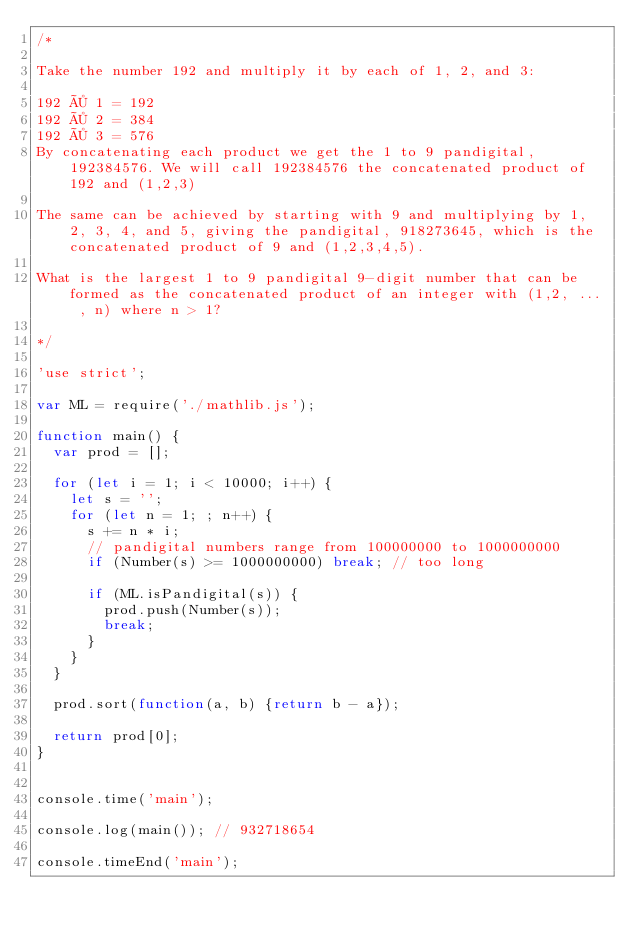Convert code to text. <code><loc_0><loc_0><loc_500><loc_500><_JavaScript_>/*

Take the number 192 and multiply it by each of 1, 2, and 3:

192 × 1 = 192
192 × 2 = 384
192 × 3 = 576
By concatenating each product we get the 1 to 9 pandigital, 192384576. We will call 192384576 the concatenated product of 192 and (1,2,3)

The same can be achieved by starting with 9 and multiplying by 1, 2, 3, 4, and 5, giving the pandigital, 918273645, which is the concatenated product of 9 and (1,2,3,4,5).

What is the largest 1 to 9 pandigital 9-digit number that can be formed as the concatenated product of an integer with (1,2, ... , n) where n > 1?

*/

'use strict';

var ML = require('./mathlib.js');

function main() {
	var prod = [];

	for (let i = 1; i < 10000; i++) {
		let s = '';
		for (let n = 1; ; n++) {
			s += n * i;
			// pandigital numbers range from 100000000 to 1000000000
			if (Number(s) >= 1000000000) break; // too long

			if (ML.isPandigital(s)) {
				prod.push(Number(s));
				break;
			}
		}
	}

	prod.sort(function(a, b) {return b - a});

	return prod[0];
}


console.time('main');

console.log(main()); // 932718654

console.timeEnd('main');
</code> 